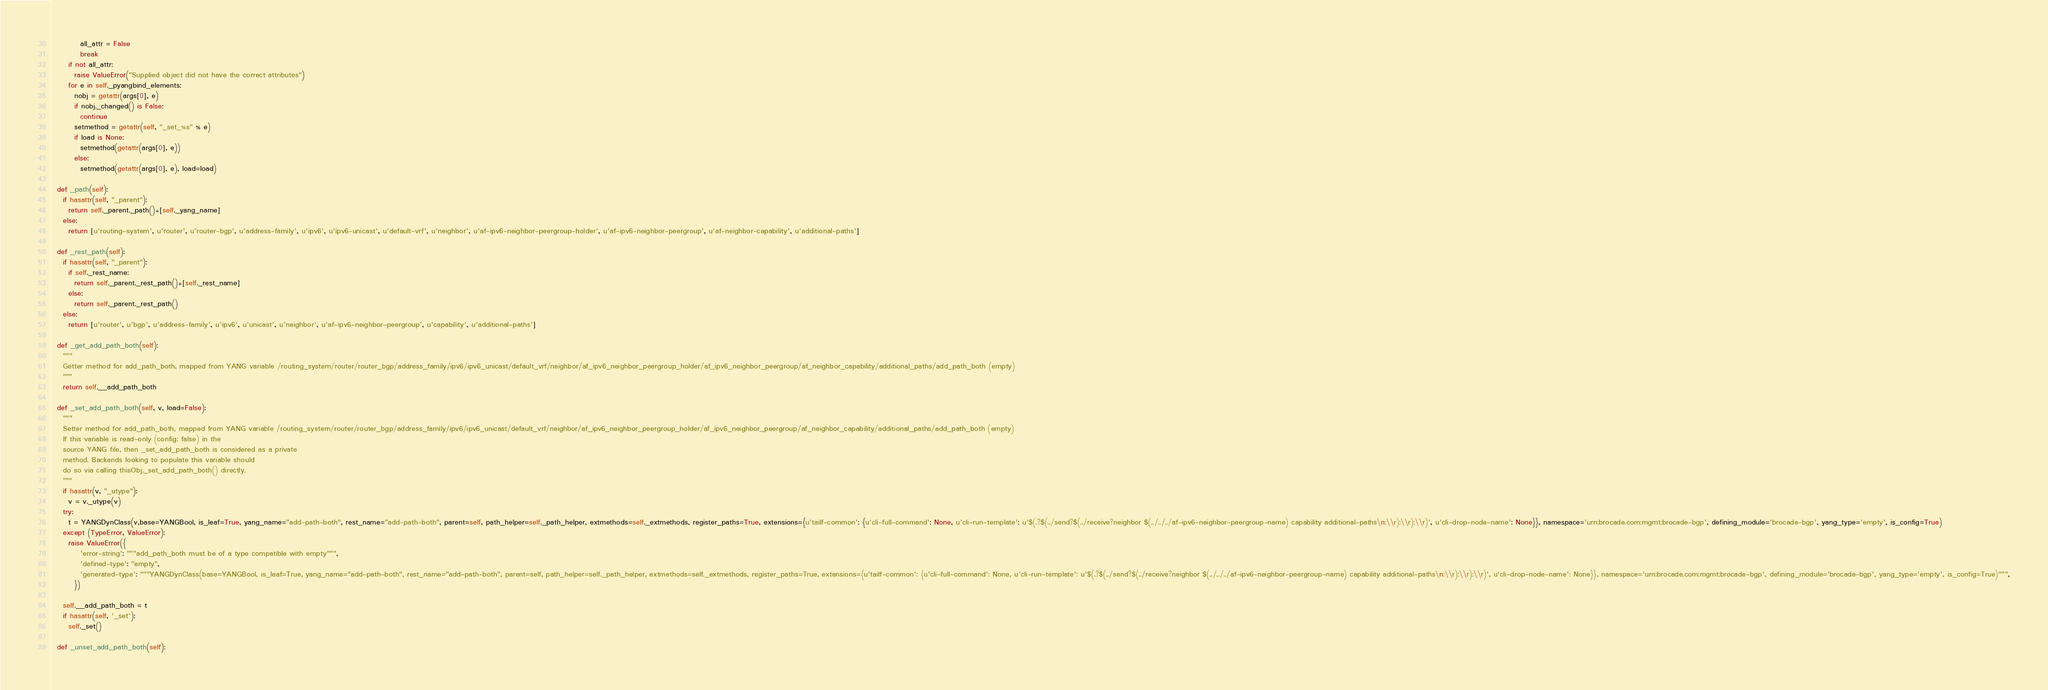<code> <loc_0><loc_0><loc_500><loc_500><_Python_>          all_attr = False
          break
      if not all_attr:
        raise ValueError("Supplied object did not have the correct attributes")
      for e in self._pyangbind_elements:
        nobj = getattr(args[0], e)
        if nobj._changed() is False:
          continue
        setmethod = getattr(self, "_set_%s" % e)
        if load is None:
          setmethod(getattr(args[0], e))
        else:
          setmethod(getattr(args[0], e), load=load)

  def _path(self):
    if hasattr(self, "_parent"):
      return self._parent._path()+[self._yang_name]
    else:
      return [u'routing-system', u'router', u'router-bgp', u'address-family', u'ipv6', u'ipv6-unicast', u'default-vrf', u'neighbor', u'af-ipv6-neighbor-peergroup-holder', u'af-ipv6-neighbor-peergroup', u'af-neighbor-capability', u'additional-paths']

  def _rest_path(self):
    if hasattr(self, "_parent"):
      if self._rest_name:
        return self._parent._rest_path()+[self._rest_name]
      else:
        return self._parent._rest_path()
    else:
      return [u'router', u'bgp', u'address-family', u'ipv6', u'unicast', u'neighbor', u'af-ipv6-neighbor-peergroup', u'capability', u'additional-paths']

  def _get_add_path_both(self):
    """
    Getter method for add_path_both, mapped from YANG variable /routing_system/router/router_bgp/address_family/ipv6/ipv6_unicast/default_vrf/neighbor/af_ipv6_neighbor_peergroup_holder/af_ipv6_neighbor_peergroup/af_neighbor_capability/additional_paths/add_path_both (empty)
    """
    return self.__add_path_both
      
  def _set_add_path_both(self, v, load=False):
    """
    Setter method for add_path_both, mapped from YANG variable /routing_system/router/router_bgp/address_family/ipv6/ipv6_unicast/default_vrf/neighbor/af_ipv6_neighbor_peergroup_holder/af_ipv6_neighbor_peergroup/af_neighbor_capability/additional_paths/add_path_both (empty)
    If this variable is read-only (config: false) in the
    source YANG file, then _set_add_path_both is considered as a private
    method. Backends looking to populate this variable should
    do so via calling thisObj._set_add_path_both() directly.
    """
    if hasattr(v, "_utype"):
      v = v._utype(v)
    try:
      t = YANGDynClass(v,base=YANGBool, is_leaf=True, yang_name="add-path-both", rest_name="add-path-both", parent=self, path_helper=self._path_helper, extmethods=self._extmethods, register_paths=True, extensions={u'tailf-common': {u'cli-full-command': None, u'cli-run-template': u'$(.?$(../send?$(../receive?neighbor $(../../../af-ipv6-neighbor-peergroup-name) capability additional-paths\n:\\r):\\r):\\r)', u'cli-drop-node-name': None}}, namespace='urn:brocade.com:mgmt:brocade-bgp', defining_module='brocade-bgp', yang_type='empty', is_config=True)
    except (TypeError, ValueError):
      raise ValueError({
          'error-string': """add_path_both must be of a type compatible with empty""",
          'defined-type': "empty",
          'generated-type': """YANGDynClass(base=YANGBool, is_leaf=True, yang_name="add-path-both", rest_name="add-path-both", parent=self, path_helper=self._path_helper, extmethods=self._extmethods, register_paths=True, extensions={u'tailf-common': {u'cli-full-command': None, u'cli-run-template': u'$(.?$(../send?$(../receive?neighbor $(../../../af-ipv6-neighbor-peergroup-name) capability additional-paths\n:\\r):\\r):\\r)', u'cli-drop-node-name': None}}, namespace='urn:brocade.com:mgmt:brocade-bgp', defining_module='brocade-bgp', yang_type='empty', is_config=True)""",
        })

    self.__add_path_both = t
    if hasattr(self, '_set'):
      self._set()

  def _unset_add_path_both(self):</code> 